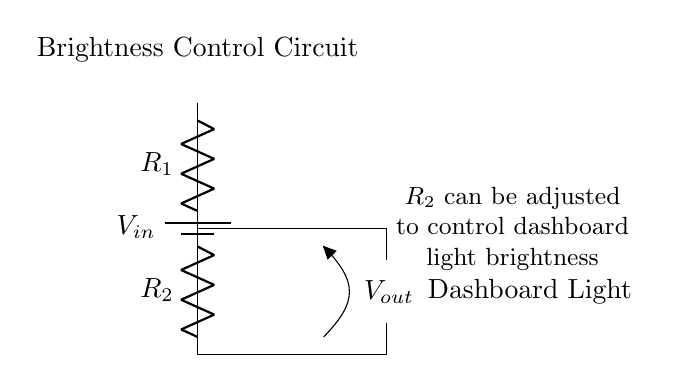What is the purpose of this circuit? The purpose of this circuit is to adjust the brightness of the dashboard light by controlling the output voltage supplied to it.
Answer: Adjust dashboard illumination What components are used in this circuit? The circuit consists of a battery, two resistors (R1 and R2), and a dashboard light represented by an LED.
Answer: Battery, Resistors, LED What does the variable Vout represent? Vout represents the output voltage across R2, which determines how much voltage is supplied to the dashboard light, affecting its brightness.
Answer: Output voltage How can the brightness of the dashboard light be adjusted? The brightness can be adjusted by modifying the value of resistor R2; changing its resistance alters Vout, thus changing the brightness of the LED.
Answer: Change R2 What is the relationship between R1, R2, and Vout in a voltage divider? The output voltage Vout can be calculated using the formula Vout equals Vin multiplied by the ratio of R2 divided by the total resistance (R1 plus R2).
Answer: Voltage divider formula What would happen if R2 is increased? Increasing R2 would result in a higher Vout, allowing more voltage to reach the LED, hence increasing its brightness.
Answer: Increase brightness What type of circuit is this? This is a basic voltage divider circuit, used commonly for adjusting voltage levels in various applications.
Answer: Voltage divider circuit 